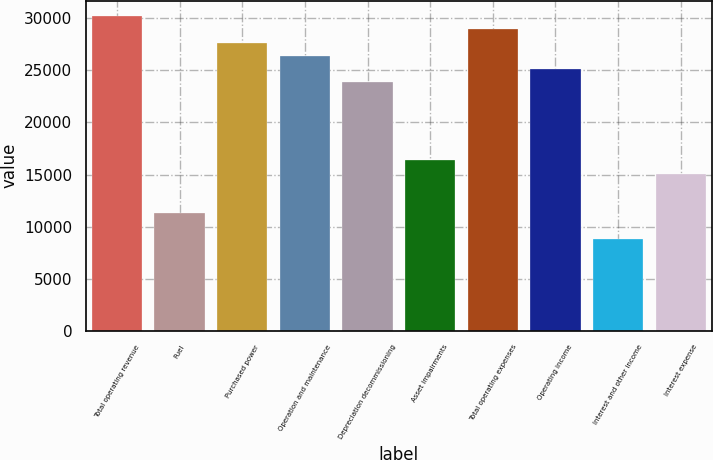Convert chart to OTSL. <chart><loc_0><loc_0><loc_500><loc_500><bar_chart><fcel>Total operating revenue<fcel>Fuel<fcel>Purchased power<fcel>Operation and maintenance<fcel>Depreciation decommissioning<fcel>Asset impairments<fcel>Total operating expenses<fcel>Operating income<fcel>Interest and other income<fcel>Interest expense<nl><fcel>30194.3<fcel>11322.9<fcel>27678.1<fcel>26420<fcel>23903.8<fcel>16355.3<fcel>28936.2<fcel>25161.9<fcel>8806.74<fcel>15097.2<nl></chart> 